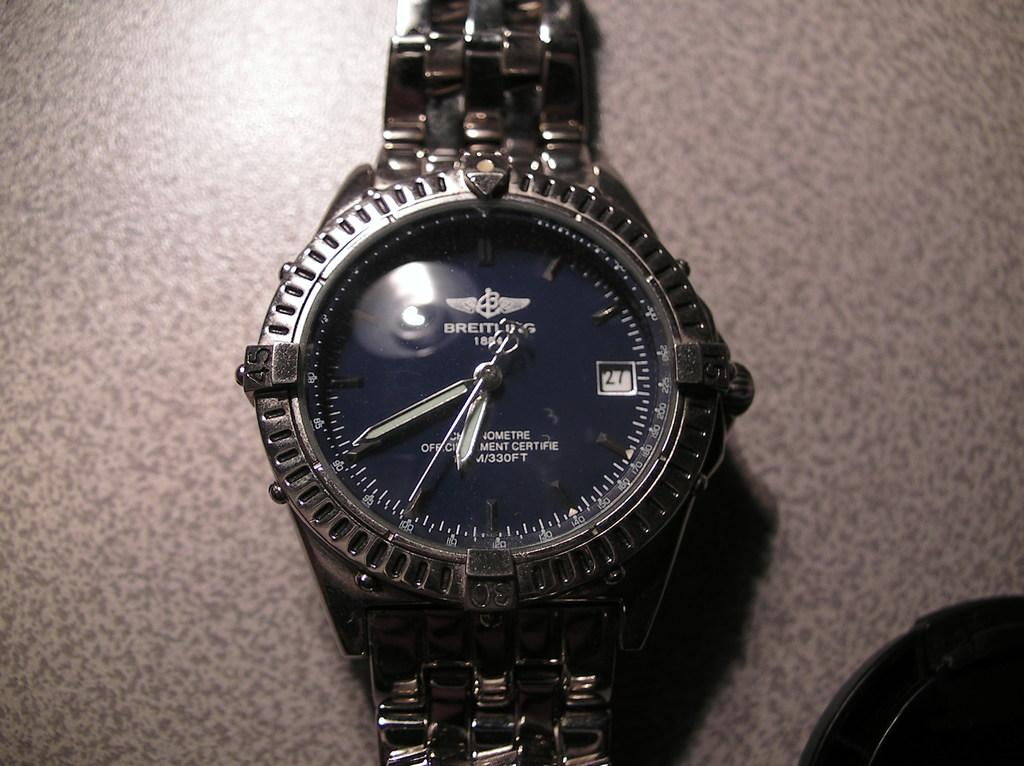<image>
Summarize the visual content of the image. A Breitiling watch sits on a table top 